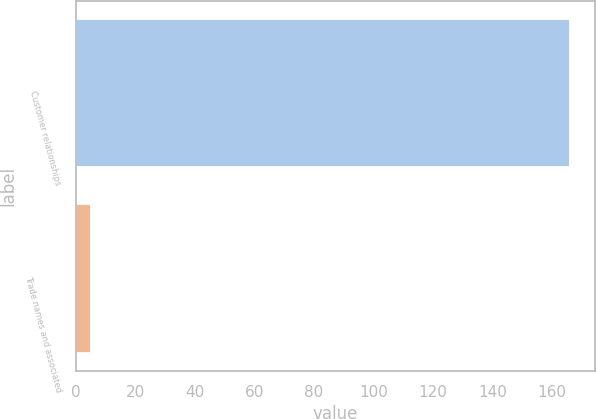Convert chart. <chart><loc_0><loc_0><loc_500><loc_500><bar_chart><fcel>Customer relationships<fcel>Trade names and associated<nl><fcel>166<fcel>5<nl></chart> 